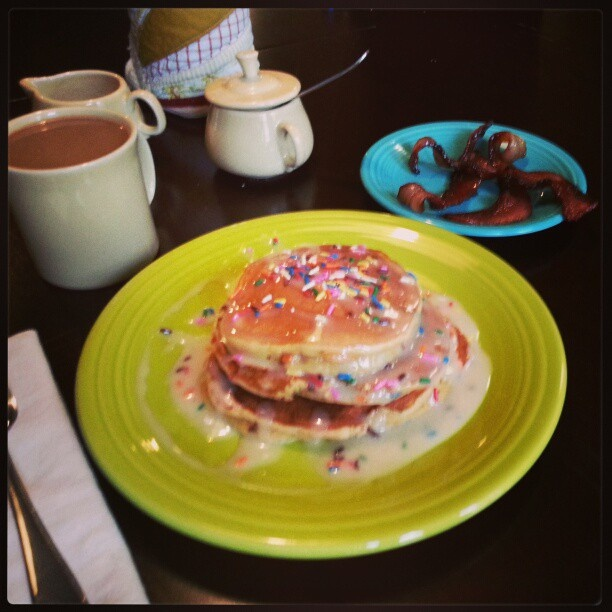Describe the objects in this image and their specific colors. I can see dining table in black, olive, darkgray, and tan tones, cup in black, darkgray, gray, and maroon tones, cake in black, tan, salmon, and red tones, spoon in black, gray, and darkgray tones, and cup in black, gray, darkgray, and tan tones in this image. 